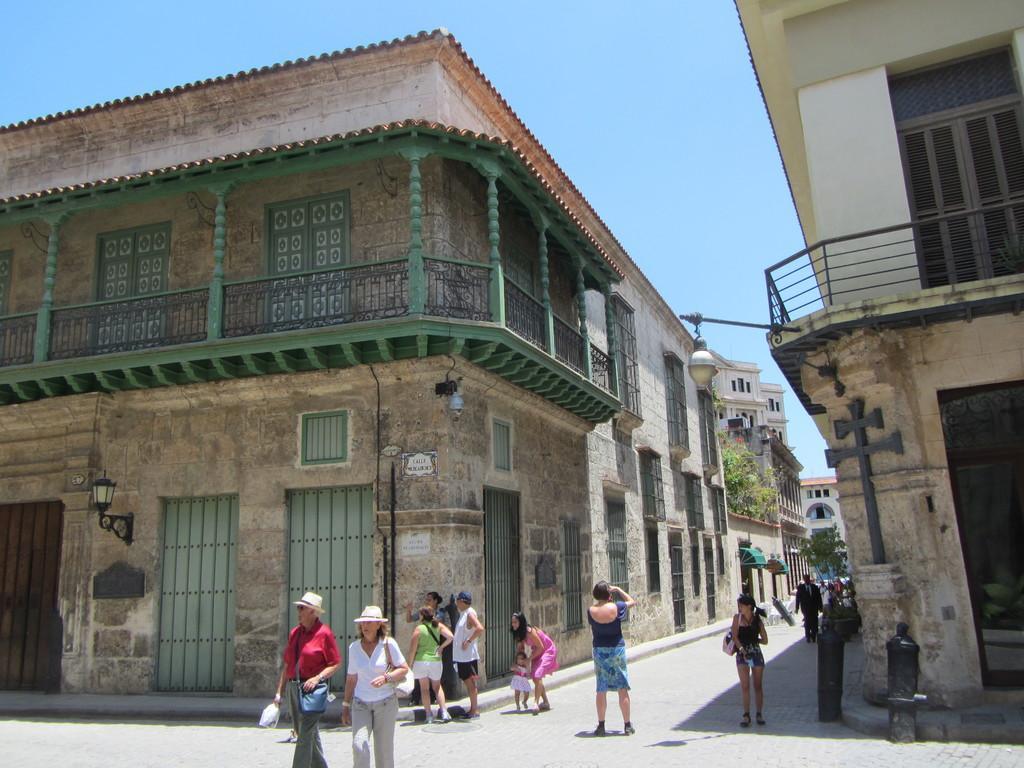Please provide a concise description of this image. In this image, there are a few people, buildings and trees. We can also see the ground with some objects. We can also see the sky. 